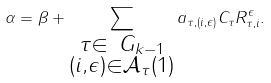Convert formula to latex. <formula><loc_0><loc_0><loc_500><loc_500>\alpha = \beta + \sum _ { \substack { \tau \in \ G _ { k - 1 } \\ ( i , \epsilon ) \in \mathcal { A } _ { \tau } ( 1 ) } } a _ { \tau , ( i , \epsilon ) } C _ { \tau } R _ { \tau , i } ^ { \epsilon } .</formula> 